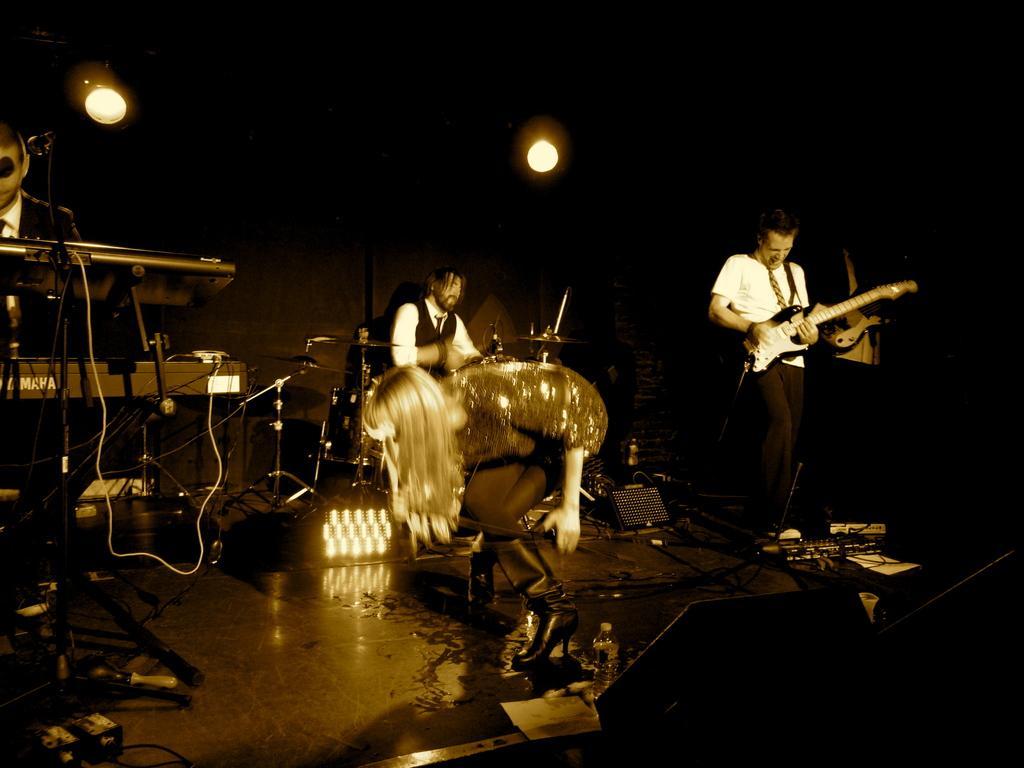Can you describe this image briefly? This picture is clicked in musical concert. Man in white shirt is holding guitar in his hand and he is playing it and he is even singing. Behind him, man in black and white shirt is playing drums. In front of him, we see woman in black dress is holding microphone in her hand and on the left corner of the picture, man in black blazer is playing keyboard. 